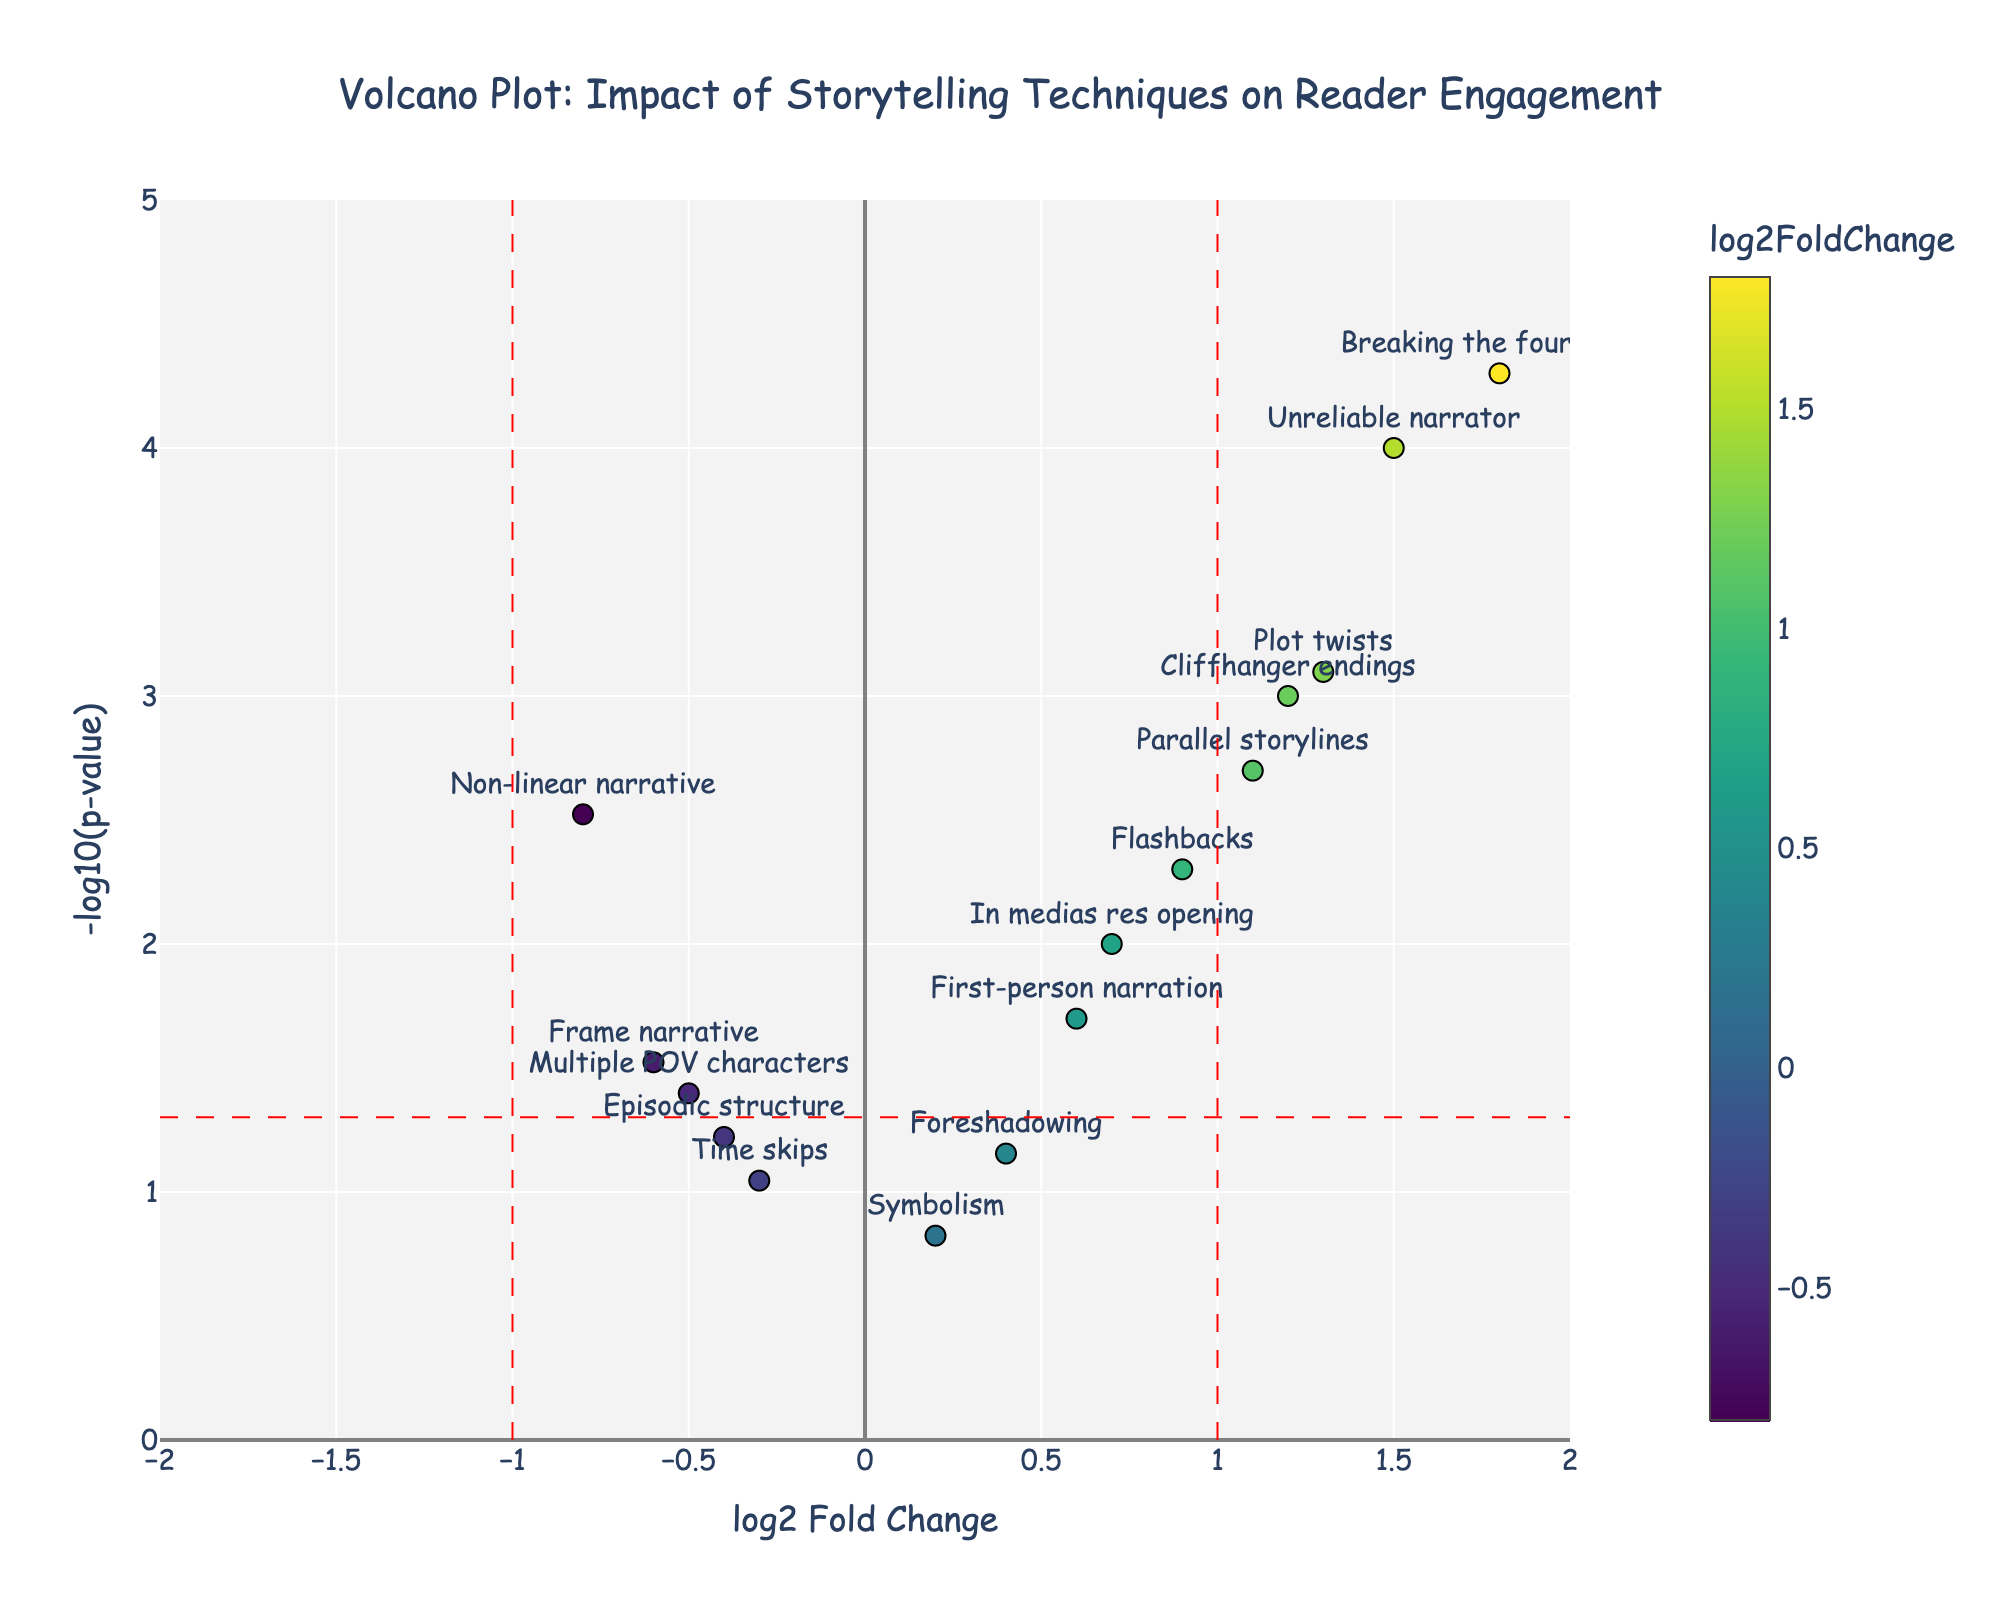What is the title of the plot? The title is usually found at the top of most figures. Here, the title is clearly mentioned in the update_layout section of the code.
Answer: "Volcano Plot: Impact of Storytelling Techniques on Reader Engagement" What does the y-axis represent? The y-axis title is defined in the layout update, indicating that it shows "-log10(p-value)".
Answer: "-log10(p-value)" Which storytelling technique has the highest -log10(p-value)? By observing the y-values in the plot, the technique with the highest y-value represents the highest -log10(p-value). "Breaking the fourth wall" is the highest point.
Answer: "Breaking the fourth wall" How many storytelling techniques have a p-value less than 0.05? In the volcano plot, points above the red horizontal line of p = 0.05 (-log10(p-value) = 1.3) have p-values less than 0.05. Count these points.
Answer: 11 Which storytelling techniques have a log2FoldChange less than -1? Techniques on the left of the red vertical line at x = -1 have log2FoldChange less than -1. Identify these points. None of the data points fall in that region.
Answer: None Which techniques have a positive impact on reader engagement (log2FoldChange > 0) and are statistically significant (p-value < 0.05)? Look for points to the right of the vertical line at x=0 (log2FoldChange > 0) and above the horizontal line at y=1.3 (-log10(p-value) > 1.3). The techniques fitting these criteria are "Cliffhanger endings", "Flashbacks", "Unreliable narrator", "In medias res opening", "Parallel storylines", and "Plot twists".
Answer: "Cliffhanger endings", "Flashbacks", "Unreliable narrator", "In medias res opening", "Parallel storylines", "Plot twists" Which technique has the highest log2FoldChange? The highest log2FoldChange is the point farthest to the right on the plot. "Breaking the fourth wall" has the highest x-value.
Answer: "Breaking the fourth wall" Are there any techniques with both large negative impact (log2FoldChange < -0.5) and statistically significant (p-value < 0.05)? Look for points to the left of the dashed vertical line at x=-0.5 and above the dashed horizontal line at y=1.3. "Non-linear narrative" and "Frame narrative" fit these criteria.
Answer: "Non-linear narrative", "Frame narrative" What does a point at (0, y) represent? A point at x=0 means log2FoldChange is 0, indicating no change, and y value tells the -log10(p-value). Since there are no points exactly at x=0, it suggests all techniques had some impact on reader engagement.
Answer: No techniques at (0, y) How do "Foreshadowing" and "Symbolism" compare in terms of statistical significance and impact on reader engagement? "Foreshadowing" has a log2FoldChange of 0.4 and a -log10(p-value) slightly above 1, while "Symbolism" has a log2FoldChange of 0.2 and a -log10(p-value) well below 1. Hence, "Foreshadowing" is more impactful and statistically significant than "Symbolism".
Answer: "Foreshadowing" is more significant and impactful than "Symbolism" 